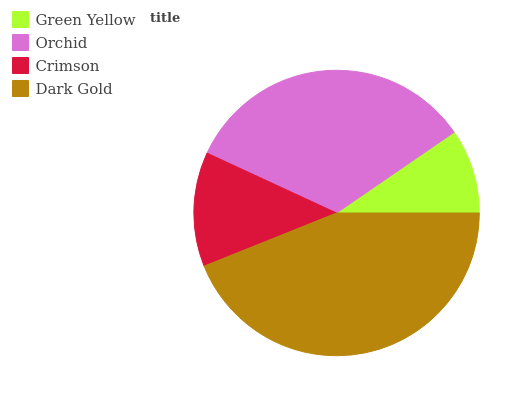Is Green Yellow the minimum?
Answer yes or no. Yes. Is Dark Gold the maximum?
Answer yes or no. Yes. Is Orchid the minimum?
Answer yes or no. No. Is Orchid the maximum?
Answer yes or no. No. Is Orchid greater than Green Yellow?
Answer yes or no. Yes. Is Green Yellow less than Orchid?
Answer yes or no. Yes. Is Green Yellow greater than Orchid?
Answer yes or no. No. Is Orchid less than Green Yellow?
Answer yes or no. No. Is Orchid the high median?
Answer yes or no. Yes. Is Crimson the low median?
Answer yes or no. Yes. Is Green Yellow the high median?
Answer yes or no. No. Is Orchid the low median?
Answer yes or no. No. 